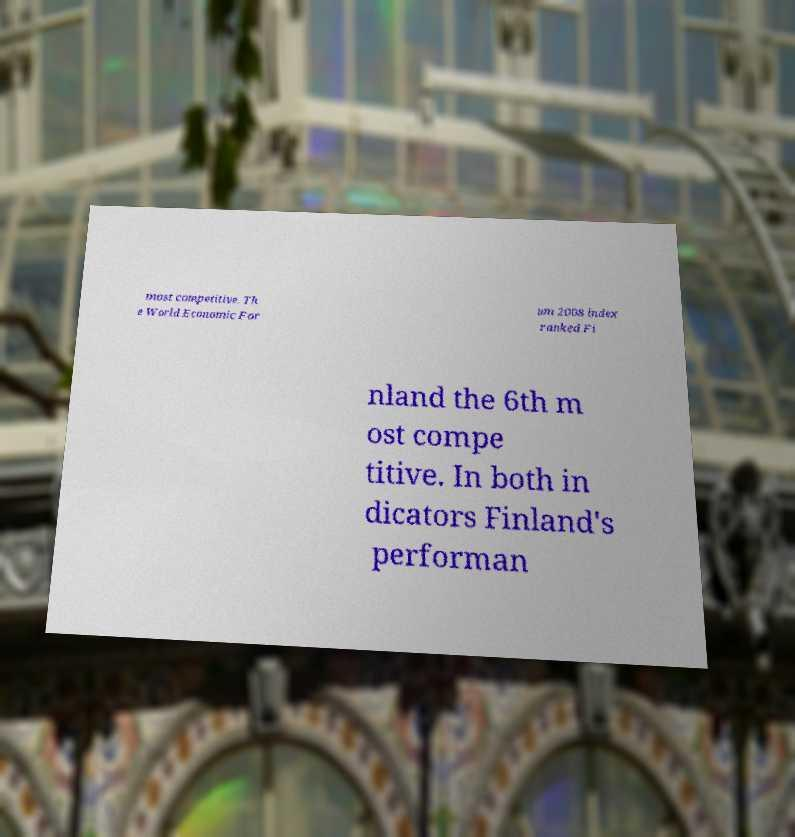Please read and relay the text visible in this image. What does it say? most competitive. Th e World Economic For um 2008 index ranked Fi nland the 6th m ost compe titive. In both in dicators Finland's performan 